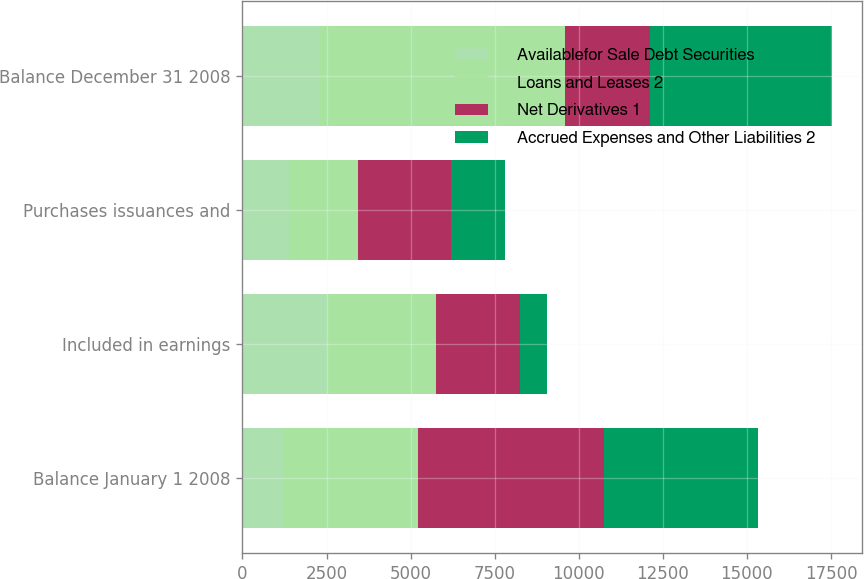Convert chart to OTSL. <chart><loc_0><loc_0><loc_500><loc_500><stacked_bar_chart><ecel><fcel>Balance January 1 2008<fcel>Included in earnings<fcel>Purchases issuances and<fcel>Balance December 31 2008<nl><fcel>Availablefor Sale Debt Securities<fcel>1203<fcel>2531<fcel>1380<fcel>2270<nl><fcel>Loans and Leases 2<fcel>4027<fcel>3222<fcel>2055<fcel>7318<nl><fcel>Net Derivatives 1<fcel>5507<fcel>2509<fcel>2754<fcel>2531<nl><fcel>Accrued Expenses and Other Liabilities 2<fcel>4590<fcel>780<fcel>1603<fcel>5413<nl></chart> 